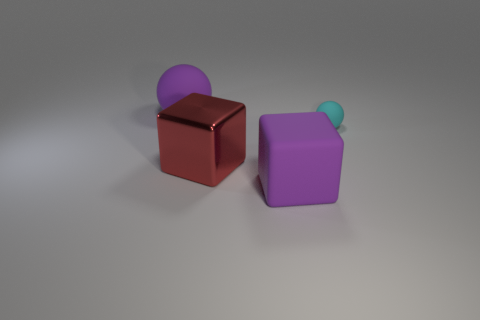Is the color of the cube that is in front of the red shiny cube the same as the large sphere?
Your answer should be compact. Yes. There is a big object that is the same color as the large sphere; what is it made of?
Give a very brief answer. Rubber. Are there fewer large red cubes that are in front of the purple cube than small cyan rubber spheres?
Make the answer very short. Yes. Is there a cube that has the same material as the tiny object?
Provide a short and direct response. Yes. There is a red metal cube; is its size the same as the purple matte object that is behind the purple cube?
Offer a terse response. Yes. Are there any big matte objects that have the same color as the large rubber block?
Give a very brief answer. Yes. Do the purple ball and the red object have the same material?
Offer a very short reply. No. What number of purple things are behind the cyan rubber thing?
Give a very brief answer. 1. There is a object that is both left of the purple rubber cube and behind the large shiny cube; what is its material?
Provide a succinct answer. Rubber. How many red metal cubes are the same size as the shiny object?
Your response must be concise. 0. 